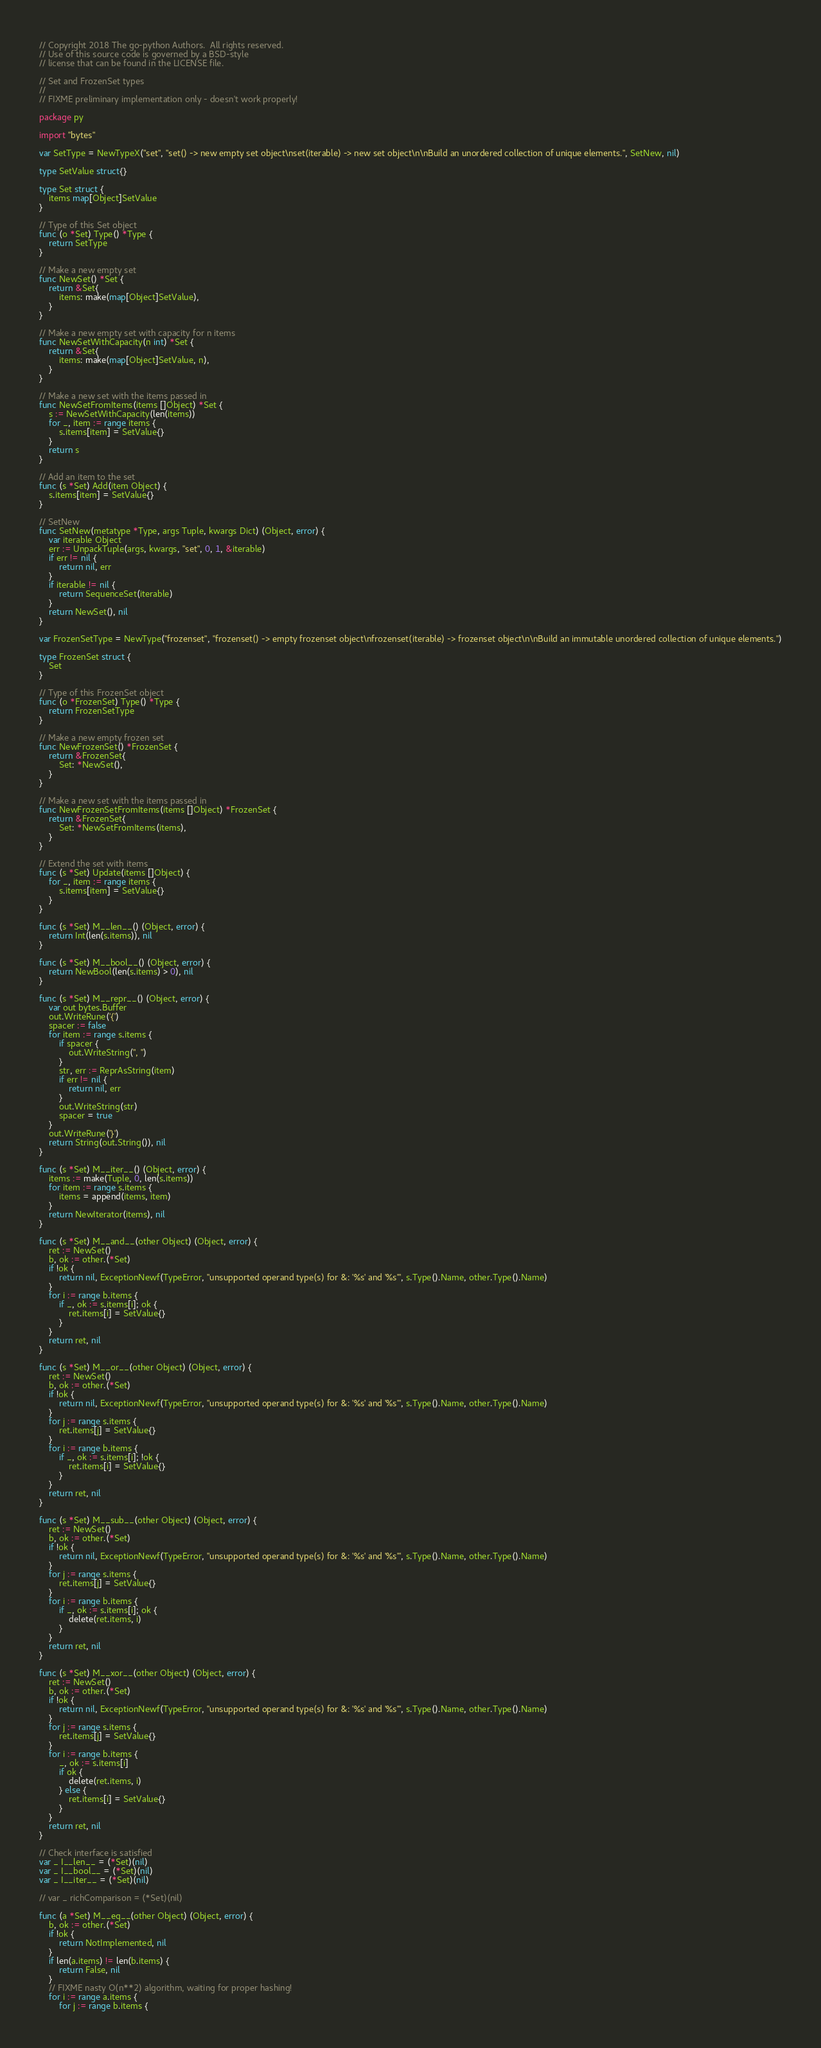<code> <loc_0><loc_0><loc_500><loc_500><_Go_>// Copyright 2018 The go-python Authors.  All rights reserved.
// Use of this source code is governed by a BSD-style
// license that can be found in the LICENSE file.

// Set and FrozenSet types
//
// FIXME preliminary implementation only - doesn't work properly!

package py

import "bytes"

var SetType = NewTypeX("set", "set() -> new empty set object\nset(iterable) -> new set object\n\nBuild an unordered collection of unique elements.", SetNew, nil)

type SetValue struct{}

type Set struct {
	items map[Object]SetValue
}

// Type of this Set object
func (o *Set) Type() *Type {
	return SetType
}

// Make a new empty set
func NewSet() *Set {
	return &Set{
		items: make(map[Object]SetValue),
	}
}

// Make a new empty set with capacity for n items
func NewSetWithCapacity(n int) *Set {
	return &Set{
		items: make(map[Object]SetValue, n),
	}
}

// Make a new set with the items passed in
func NewSetFromItems(items []Object) *Set {
	s := NewSetWithCapacity(len(items))
	for _, item := range items {
		s.items[item] = SetValue{}
	}
	return s
}

// Add an item to the set
func (s *Set) Add(item Object) {
	s.items[item] = SetValue{}
}

// SetNew
func SetNew(metatype *Type, args Tuple, kwargs Dict) (Object, error) {
	var iterable Object
	err := UnpackTuple(args, kwargs, "set", 0, 1, &iterable)
	if err != nil {
		return nil, err
	}
	if iterable != nil {
		return SequenceSet(iterable)
	}
	return NewSet(), nil
}

var FrozenSetType = NewType("frozenset", "frozenset() -> empty frozenset object\nfrozenset(iterable) -> frozenset object\n\nBuild an immutable unordered collection of unique elements.")

type FrozenSet struct {
	Set
}

// Type of this FrozenSet object
func (o *FrozenSet) Type() *Type {
	return FrozenSetType
}

// Make a new empty frozen set
func NewFrozenSet() *FrozenSet {
	return &FrozenSet{
		Set: *NewSet(),
	}
}

// Make a new set with the items passed in
func NewFrozenSetFromItems(items []Object) *FrozenSet {
	return &FrozenSet{
		Set: *NewSetFromItems(items),
	}
}

// Extend the set with items
func (s *Set) Update(items []Object) {
	for _, item := range items {
		s.items[item] = SetValue{}
	}
}

func (s *Set) M__len__() (Object, error) {
	return Int(len(s.items)), nil
}

func (s *Set) M__bool__() (Object, error) {
	return NewBool(len(s.items) > 0), nil
}

func (s *Set) M__repr__() (Object, error) {
	var out bytes.Buffer
	out.WriteRune('{')
	spacer := false
	for item := range s.items {
		if spacer {
			out.WriteString(", ")
		}
		str, err := ReprAsString(item)
		if err != nil {
			return nil, err
		}
		out.WriteString(str)
		spacer = true
	}
	out.WriteRune('}')
	return String(out.String()), nil
}

func (s *Set) M__iter__() (Object, error) {
	items := make(Tuple, 0, len(s.items))
	for item := range s.items {
		items = append(items, item)
	}
	return NewIterator(items), nil
}

func (s *Set) M__and__(other Object) (Object, error) {
	ret := NewSet()
	b, ok := other.(*Set)
	if !ok {
		return nil, ExceptionNewf(TypeError, "unsupported operand type(s) for &: '%s' and '%s'", s.Type().Name, other.Type().Name)
	}
	for i := range b.items {
		if _, ok := s.items[i]; ok {
			ret.items[i] = SetValue{}
		}
	}
	return ret, nil
}

func (s *Set) M__or__(other Object) (Object, error) {
	ret := NewSet()
	b, ok := other.(*Set)
	if !ok {
		return nil, ExceptionNewf(TypeError, "unsupported operand type(s) for &: '%s' and '%s'", s.Type().Name, other.Type().Name)
	}
	for j := range s.items {
		ret.items[j] = SetValue{}
	}
	for i := range b.items {
		if _, ok := s.items[i]; !ok {
			ret.items[i] = SetValue{}
		}
	}
	return ret, nil
}

func (s *Set) M__sub__(other Object) (Object, error) {
	ret := NewSet()
	b, ok := other.(*Set)
	if !ok {
		return nil, ExceptionNewf(TypeError, "unsupported operand type(s) for &: '%s' and '%s'", s.Type().Name, other.Type().Name)
	}
	for j := range s.items {
		ret.items[j] = SetValue{}
	}
	for i := range b.items {
		if _, ok := s.items[i]; ok {
			delete(ret.items, i)
		}
	}
	return ret, nil
}

func (s *Set) M__xor__(other Object) (Object, error) {
	ret := NewSet()
	b, ok := other.(*Set)
	if !ok {
		return nil, ExceptionNewf(TypeError, "unsupported operand type(s) for &: '%s' and '%s'", s.Type().Name, other.Type().Name)
	}
	for j := range s.items {
		ret.items[j] = SetValue{}
	}
	for i := range b.items {
		_, ok := s.items[i]
		if ok {
			delete(ret.items, i)
		} else {
			ret.items[i] = SetValue{}
		}
	}
	return ret, nil
}

// Check interface is satisfied
var _ I__len__ = (*Set)(nil)
var _ I__bool__ = (*Set)(nil)
var _ I__iter__ = (*Set)(nil)

// var _ richComparison = (*Set)(nil)

func (a *Set) M__eq__(other Object) (Object, error) {
	b, ok := other.(*Set)
	if !ok {
		return NotImplemented, nil
	}
	if len(a.items) != len(b.items) {
		return False, nil
	}
	// FIXME nasty O(n**2) algorithm, waiting for proper hashing!
	for i := range a.items {
		for j := range b.items {</code> 